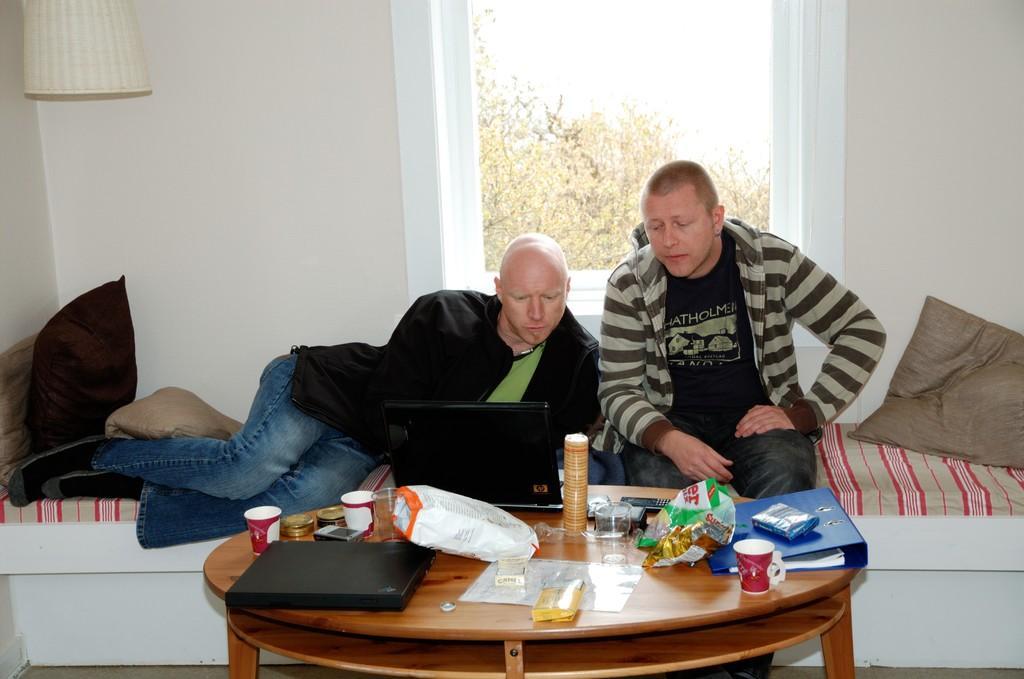How would you summarize this image in a sentence or two? In this image there are two persons. on the right side the person is sitting on the sofa and he is looking at the laptop the left side the person with wearing a black colour jacket and a jeans which is blue in colour is doing work on the laptop which is in front of him and there is a round table in front of them on that table there is a file,cup, two mugs and other stuffs. On the right side there is a cushion and on the left side there are two cushions and a lamp hanging. In the background there is a window and outside of the window some trees are visible. 